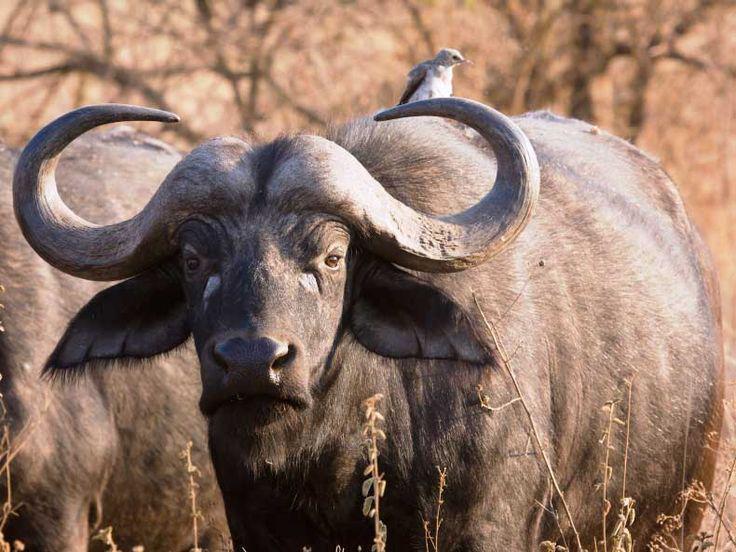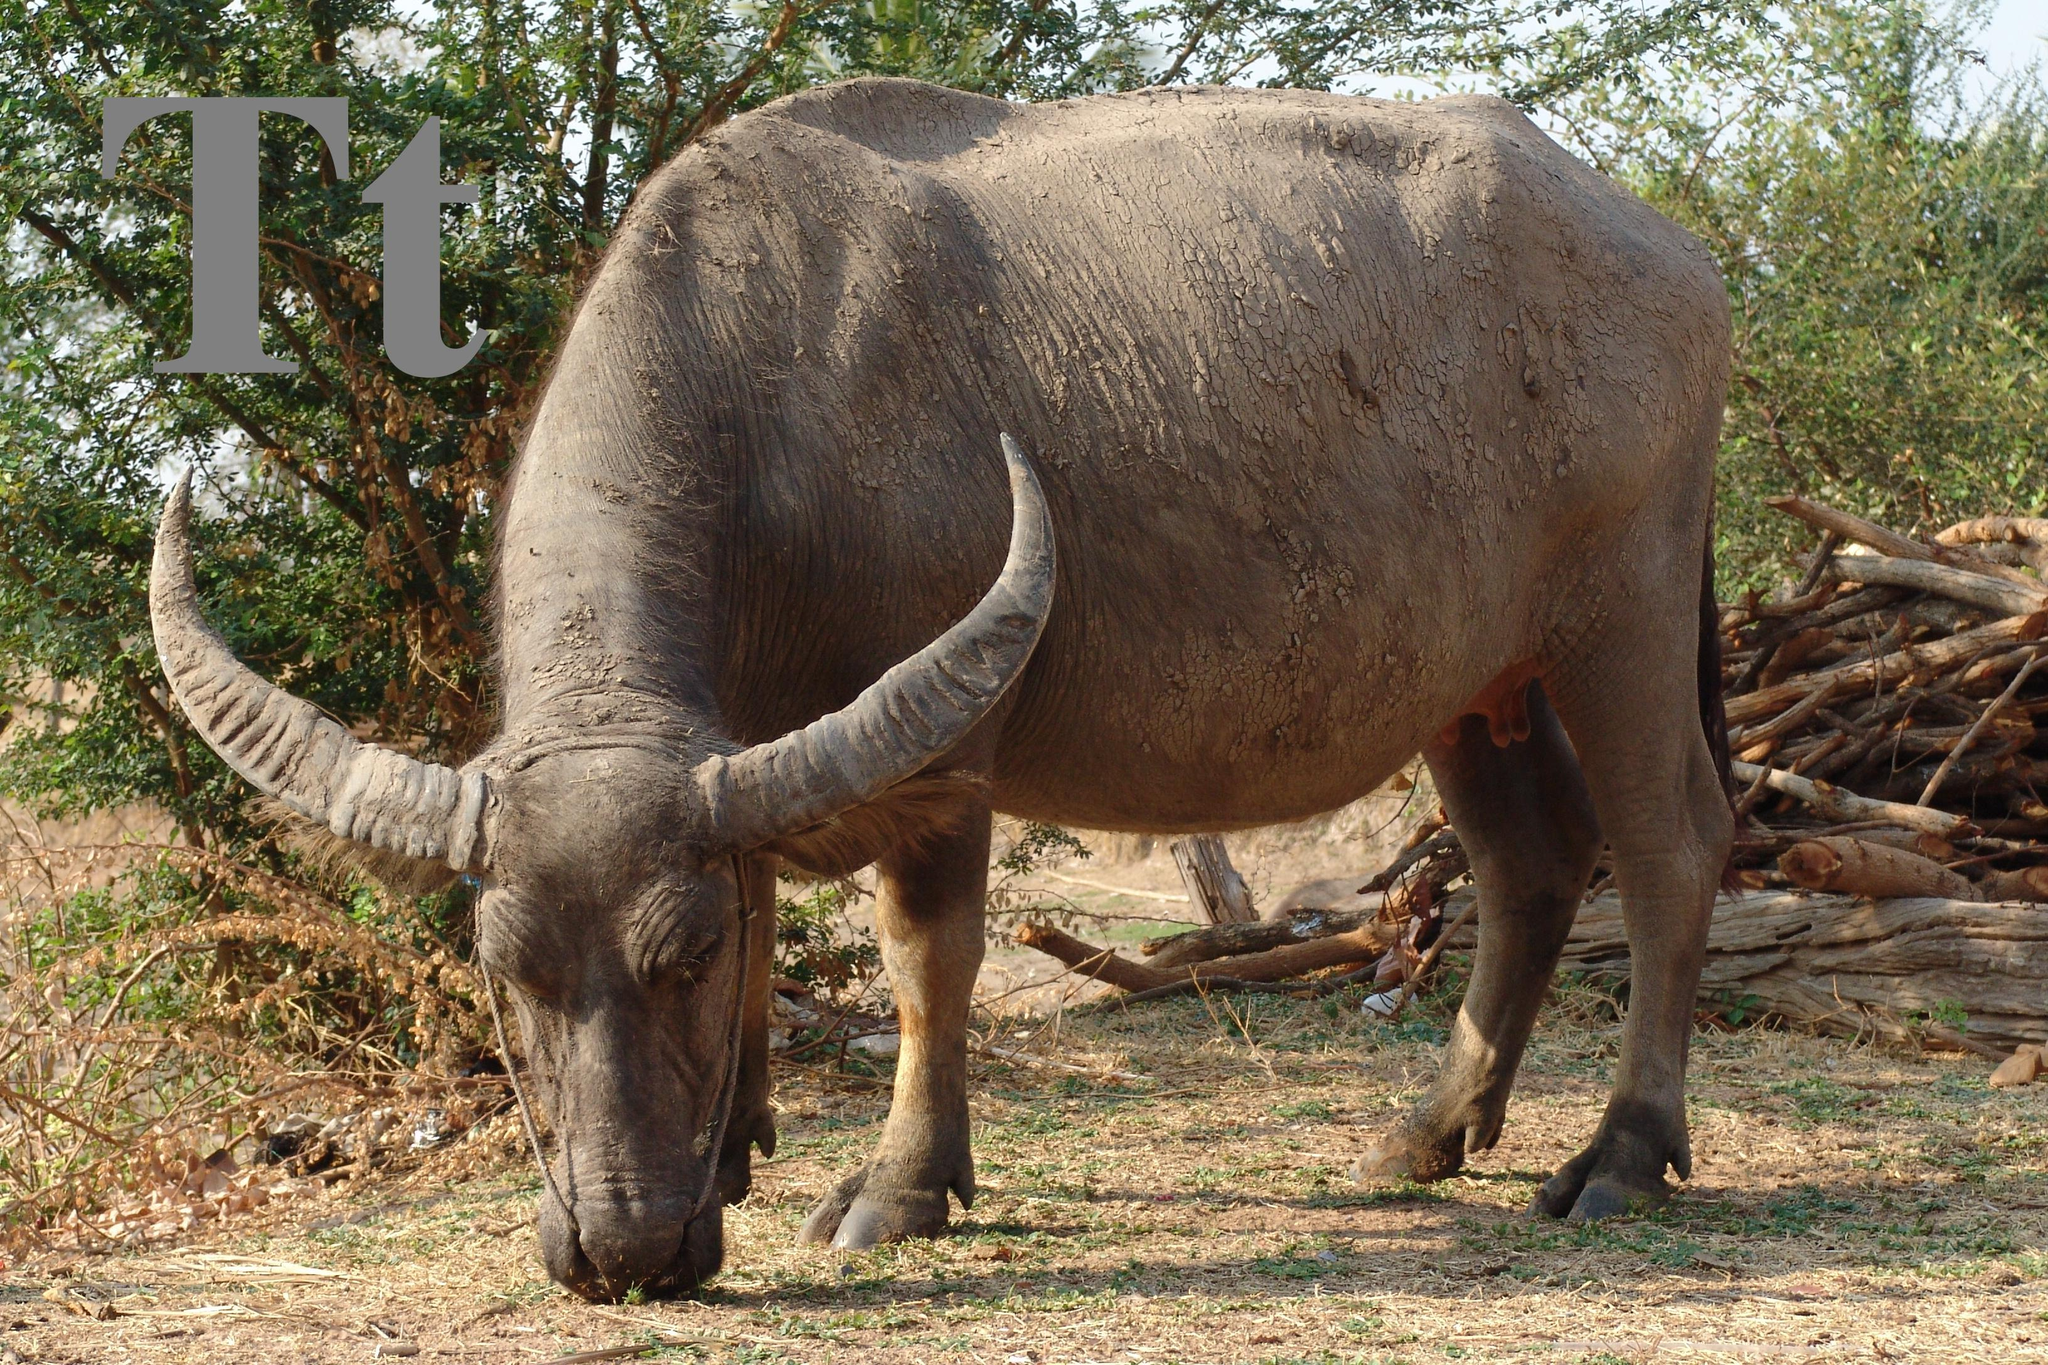The first image is the image on the left, the second image is the image on the right. For the images shown, is this caption "An image shows exactly one water buffalo standing in wet area." true? Answer yes or no. No. The first image is the image on the left, the second image is the image on the right. Given the left and right images, does the statement "The buffalo in the right image has its head down in the grass." hold true? Answer yes or no. Yes. 